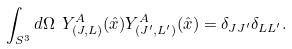Convert formula to latex. <formula><loc_0><loc_0><loc_500><loc_500>\int _ { S ^ { 3 } } d \Omega \ Y ^ { A } _ { ( J , L ) } ( \hat { x } ) Y ^ { A } _ { ( J ^ { \prime } , L ^ { \prime } ) } ( \hat { x } ) = \delta _ { J J ^ { \prime } } \delta _ { L L ^ { \prime } } .</formula> 